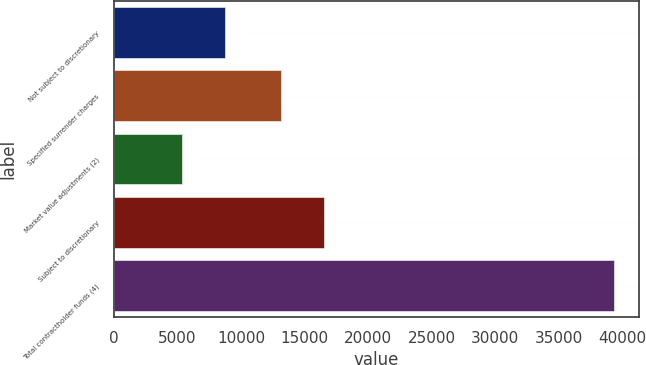<chart> <loc_0><loc_0><loc_500><loc_500><bar_chart><fcel>Not subject to discretionary<fcel>Specified surrender charges<fcel>Market value adjustments (2)<fcel>Subject to discretionary<fcel>Total contractholder funds (4)<nl><fcel>8775.7<fcel>13170<fcel>5382<fcel>16563.7<fcel>39319<nl></chart> 